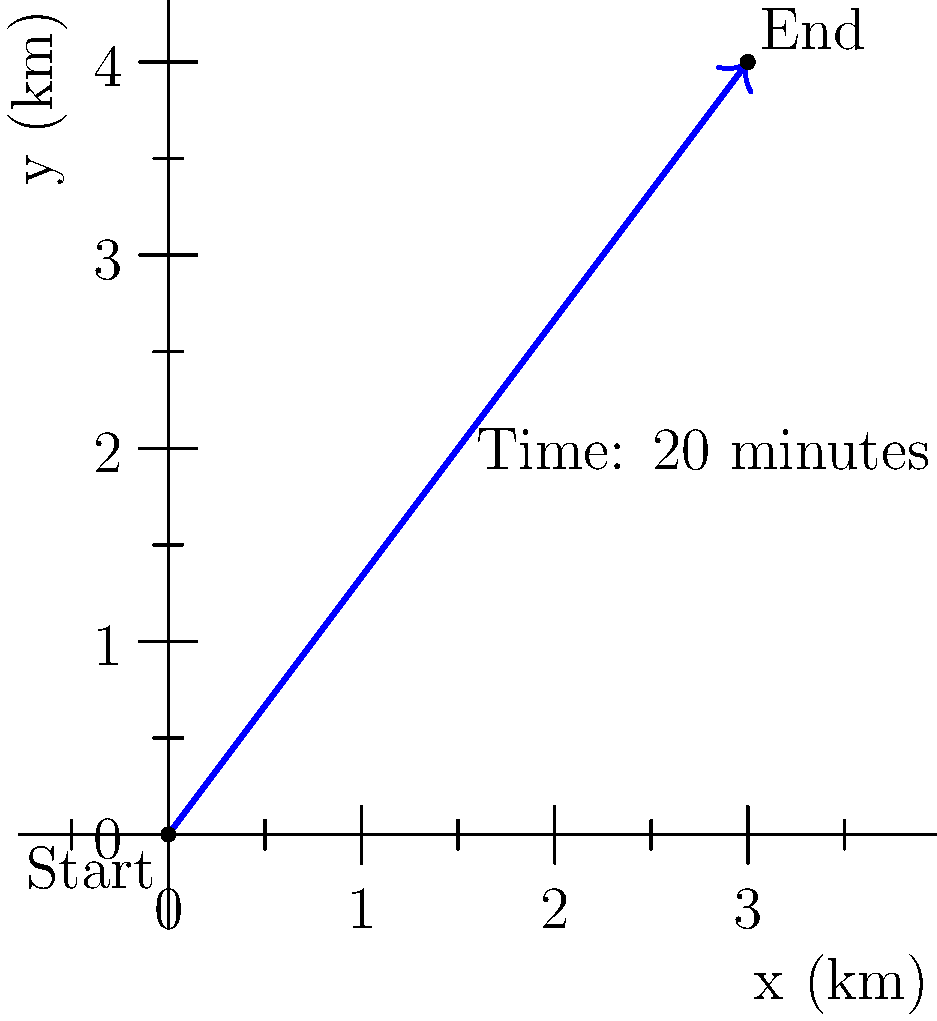Based on witness reports, a suspect fled from the scene of a crime. The diagram shows the suspect's estimated escape route. If the suspect traveled from the start point (0,0) to the end point (3,4) in 20 minutes, calculate the velocity vector of the suspect's escape route in km/h. To calculate the velocity vector, we need to follow these steps:

1) First, determine the displacement vector:
   $\vec{r} = (3\text{ km}, 4\text{ km})$

2) Calculate the magnitude of the displacement:
   $|\vec{r}| = \sqrt{3^2 + 4^2} = 5\text{ km}$

3) Convert the time from minutes to hours:
   $20\text{ minutes} = \frac{1}{3}\text{ hour}$

4) Calculate the speed:
   $\text{speed} = \frac{\text{distance}}{\text{time}} = \frac{5\text{ km}}{\frac{1}{3}\text{ hour}} = 15\text{ km/h}$

5) The velocity vector has the same direction as the displacement vector, but its magnitude is the speed. To get the components of the velocity vector, we scale the displacement vector:

   $\vec{v} = 15 \cdot \frac{(3,4)}{5} = (9,12)\text{ km/h}$

Therefore, the velocity vector is $(9,12)\text{ km/h}$.
Answer: $(9,12)\text{ km/h}$ 